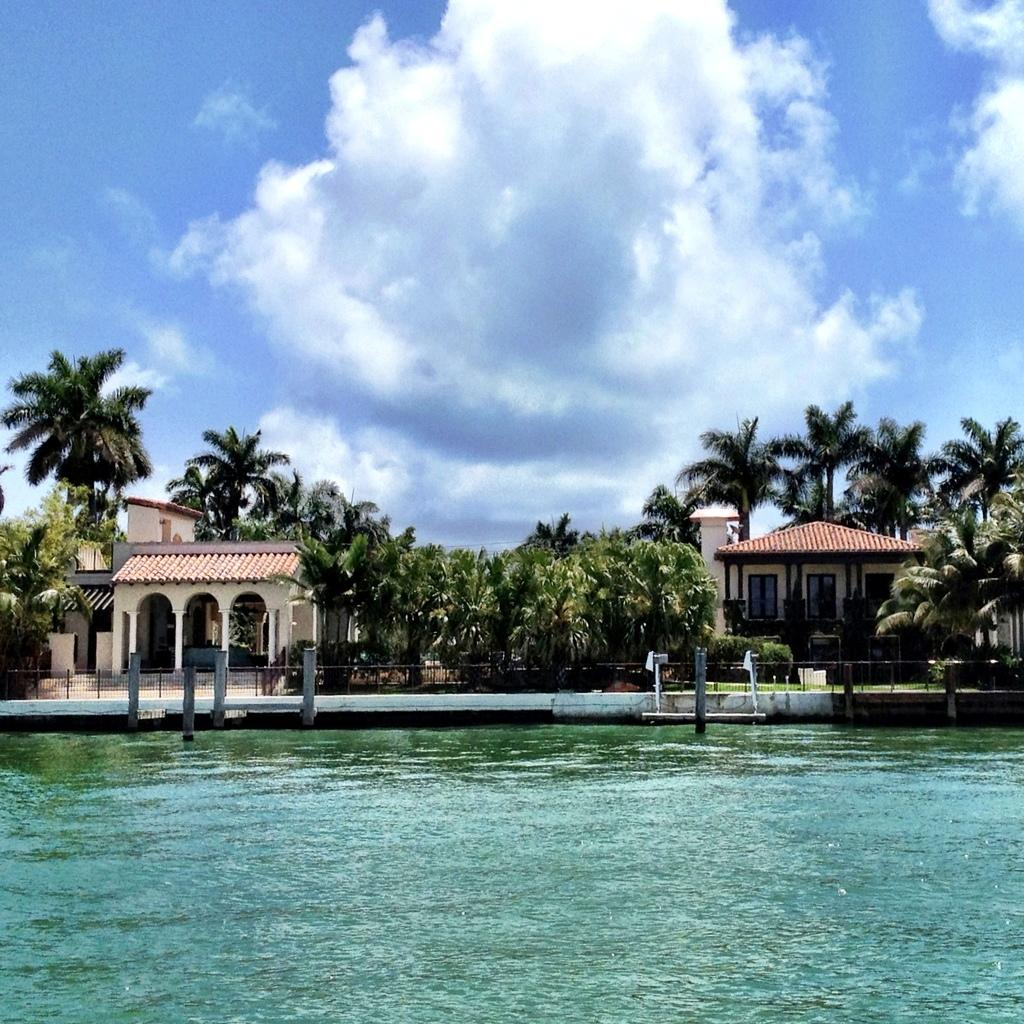What is at the bottom of the image? There is water at the bottom of the image. What can be seen in the middle of the image? There are trees in the middle of the image. What structures are located beside the trees? There are houses beside the trees. What is visible at the top of the image? The sky is visible at the top of the image. How would you describe the weather based on the sky? The sky appears to be sunny, suggesting a clear and bright day. Where are the bells located in the image? There are no bells present in the image. What type of toys can be seen in the water at the bottom of the image? There are no toys present in the image; it only shows water at the bottom. 